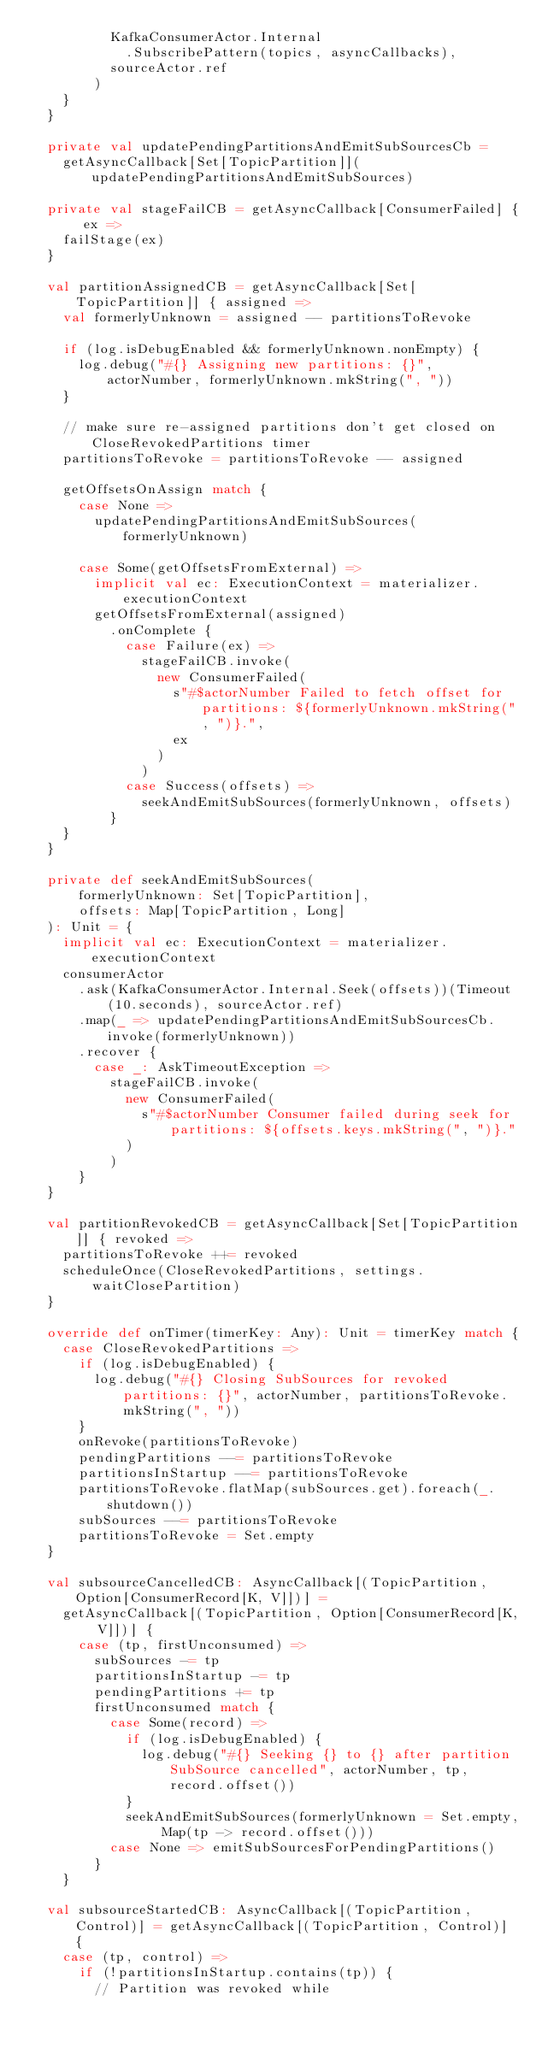Convert code to text. <code><loc_0><loc_0><loc_500><loc_500><_Scala_>          KafkaConsumerActor.Internal
            .SubscribePattern(topics, asyncCallbacks),
          sourceActor.ref
        )
    }
  }

  private val updatePendingPartitionsAndEmitSubSourcesCb =
    getAsyncCallback[Set[TopicPartition]](updatePendingPartitionsAndEmitSubSources)

  private val stageFailCB = getAsyncCallback[ConsumerFailed] { ex =>
    failStage(ex)
  }

  val partitionAssignedCB = getAsyncCallback[Set[TopicPartition]] { assigned =>
    val formerlyUnknown = assigned -- partitionsToRevoke

    if (log.isDebugEnabled && formerlyUnknown.nonEmpty) {
      log.debug("#{} Assigning new partitions: {}", actorNumber, formerlyUnknown.mkString(", "))
    }

    // make sure re-assigned partitions don't get closed on CloseRevokedPartitions timer
    partitionsToRevoke = partitionsToRevoke -- assigned

    getOffsetsOnAssign match {
      case None =>
        updatePendingPartitionsAndEmitSubSources(formerlyUnknown)

      case Some(getOffsetsFromExternal) =>
        implicit val ec: ExecutionContext = materializer.executionContext
        getOffsetsFromExternal(assigned)
          .onComplete {
            case Failure(ex) =>
              stageFailCB.invoke(
                new ConsumerFailed(
                  s"#$actorNumber Failed to fetch offset for partitions: ${formerlyUnknown.mkString(", ")}.",
                  ex
                )
              )
            case Success(offsets) =>
              seekAndEmitSubSources(formerlyUnknown, offsets)
          }
    }
  }

  private def seekAndEmitSubSources(
      formerlyUnknown: Set[TopicPartition],
      offsets: Map[TopicPartition, Long]
  ): Unit = {
    implicit val ec: ExecutionContext = materializer.executionContext
    consumerActor
      .ask(KafkaConsumerActor.Internal.Seek(offsets))(Timeout(10.seconds), sourceActor.ref)
      .map(_ => updatePendingPartitionsAndEmitSubSourcesCb.invoke(formerlyUnknown))
      .recover {
        case _: AskTimeoutException =>
          stageFailCB.invoke(
            new ConsumerFailed(
              s"#$actorNumber Consumer failed during seek for partitions: ${offsets.keys.mkString(", ")}."
            )
          )
      }
  }

  val partitionRevokedCB = getAsyncCallback[Set[TopicPartition]] { revoked =>
    partitionsToRevoke ++= revoked
    scheduleOnce(CloseRevokedPartitions, settings.waitClosePartition)
  }

  override def onTimer(timerKey: Any): Unit = timerKey match {
    case CloseRevokedPartitions =>
      if (log.isDebugEnabled) {
        log.debug("#{} Closing SubSources for revoked partitions: {}", actorNumber, partitionsToRevoke.mkString(", "))
      }
      onRevoke(partitionsToRevoke)
      pendingPartitions --= partitionsToRevoke
      partitionsInStartup --= partitionsToRevoke
      partitionsToRevoke.flatMap(subSources.get).foreach(_.shutdown())
      subSources --= partitionsToRevoke
      partitionsToRevoke = Set.empty
  }

  val subsourceCancelledCB: AsyncCallback[(TopicPartition, Option[ConsumerRecord[K, V]])] =
    getAsyncCallback[(TopicPartition, Option[ConsumerRecord[K, V]])] {
      case (tp, firstUnconsumed) =>
        subSources -= tp
        partitionsInStartup -= tp
        pendingPartitions += tp
        firstUnconsumed match {
          case Some(record) =>
            if (log.isDebugEnabled) {
              log.debug("#{} Seeking {} to {} after partition SubSource cancelled", actorNumber, tp, record.offset())
            }
            seekAndEmitSubSources(formerlyUnknown = Set.empty, Map(tp -> record.offset()))
          case None => emitSubSourcesForPendingPartitions()
        }
    }

  val subsourceStartedCB: AsyncCallback[(TopicPartition, Control)] = getAsyncCallback[(TopicPartition, Control)] {
    case (tp, control) =>
      if (!partitionsInStartup.contains(tp)) {
        // Partition was revoked while</code> 